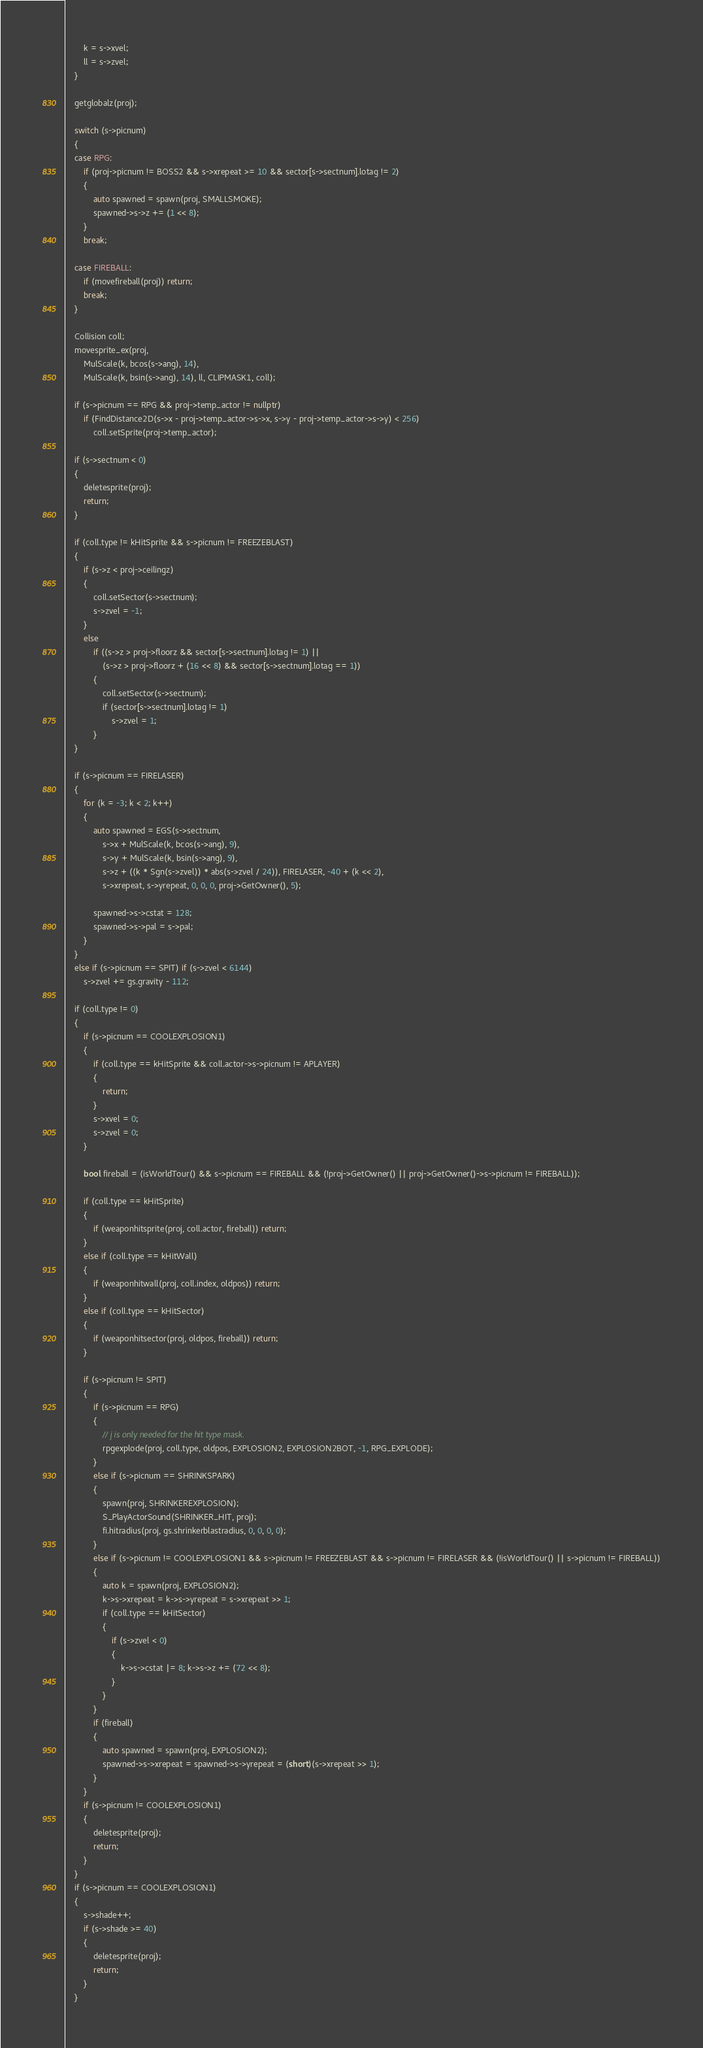<code> <loc_0><loc_0><loc_500><loc_500><_C++_>		k = s->xvel;
		ll = s->zvel;
	}

	getglobalz(proj);

	switch (s->picnum)
	{
	case RPG:
		if (proj->picnum != BOSS2 && s->xrepeat >= 10 && sector[s->sectnum].lotag != 2)
		{
			auto spawned = spawn(proj, SMALLSMOKE);
			spawned->s->z += (1 << 8);
		}
		break;

	case FIREBALL:
		if (movefireball(proj)) return;
		break;
	}

	Collision coll;
	movesprite_ex(proj,
		MulScale(k, bcos(s->ang), 14),
		MulScale(k, bsin(s->ang), 14), ll, CLIPMASK1, coll);

	if (s->picnum == RPG && proj->temp_actor != nullptr)
		if (FindDistance2D(s->x - proj->temp_actor->s->x, s->y - proj->temp_actor->s->y) < 256)
			coll.setSprite(proj->temp_actor);

	if (s->sectnum < 0)
	{
		deletesprite(proj);
		return;
	}

	if (coll.type != kHitSprite && s->picnum != FREEZEBLAST)
	{
		if (s->z < proj->ceilingz)
		{
			coll.setSector(s->sectnum);
			s->zvel = -1;
		}
		else
			if ((s->z > proj->floorz && sector[s->sectnum].lotag != 1) ||
				(s->z > proj->floorz + (16 << 8) && sector[s->sectnum].lotag == 1))
			{
				coll.setSector(s->sectnum);
				if (sector[s->sectnum].lotag != 1)
					s->zvel = 1;
			}
	}

	if (s->picnum == FIRELASER)
	{
		for (k = -3; k < 2; k++)
		{
			auto spawned = EGS(s->sectnum,
				s->x + MulScale(k, bcos(s->ang), 9),
				s->y + MulScale(k, bsin(s->ang), 9),
				s->z + ((k * Sgn(s->zvel)) * abs(s->zvel / 24)), FIRELASER, -40 + (k << 2),
				s->xrepeat, s->yrepeat, 0, 0, 0, proj->GetOwner(), 5);

			spawned->s->cstat = 128;
			spawned->s->pal = s->pal;
		}
	}
	else if (s->picnum == SPIT) if (s->zvel < 6144)
		s->zvel += gs.gravity - 112;

	if (coll.type != 0)
	{
		if (s->picnum == COOLEXPLOSION1)
		{
			if (coll.type == kHitSprite && coll.actor->s->picnum != APLAYER)
			{
				return;
			}
			s->xvel = 0;
			s->zvel = 0;
		}

		bool fireball = (isWorldTour() && s->picnum == FIREBALL && (!proj->GetOwner() || proj->GetOwner()->s->picnum != FIREBALL));

		if (coll.type == kHitSprite)
		{
			if (weaponhitsprite(proj, coll.actor, fireball)) return;
		}
		else if (coll.type == kHitWall)
		{
			if (weaponhitwall(proj, coll.index, oldpos)) return;
		}
		else if (coll.type == kHitSector)
		{
			if (weaponhitsector(proj, oldpos, fireball)) return;
		}

		if (s->picnum != SPIT)
		{
			if (s->picnum == RPG)
			{
				// j is only needed for the hit type mask.
				rpgexplode(proj, coll.type, oldpos, EXPLOSION2, EXPLOSION2BOT, -1, RPG_EXPLODE);
			}
			else if (s->picnum == SHRINKSPARK)
			{
				spawn(proj, SHRINKEREXPLOSION);
				S_PlayActorSound(SHRINKER_HIT, proj);
				fi.hitradius(proj, gs.shrinkerblastradius, 0, 0, 0, 0);
			}
			else if (s->picnum != COOLEXPLOSION1 && s->picnum != FREEZEBLAST && s->picnum != FIRELASER && (!isWorldTour() || s->picnum != FIREBALL))
			{
				auto k = spawn(proj, EXPLOSION2);
				k->s->xrepeat = k->s->yrepeat = s->xrepeat >> 1;
				if (coll.type == kHitSector)
				{
					if (s->zvel < 0)
					{
						k->s->cstat |= 8; k->s->z += (72 << 8);
					}
				}
			}
			if (fireball)
			{
				auto spawned = spawn(proj, EXPLOSION2);
				spawned->s->xrepeat = spawned->s->yrepeat = (short)(s->xrepeat >> 1);
			}
		}
		if (s->picnum != COOLEXPLOSION1)
		{
			deletesprite(proj);
			return;
		}
	}
	if (s->picnum == COOLEXPLOSION1)
	{
		s->shade++;
		if (s->shade >= 40)
		{
			deletesprite(proj);
			return;
		}
	}</code> 